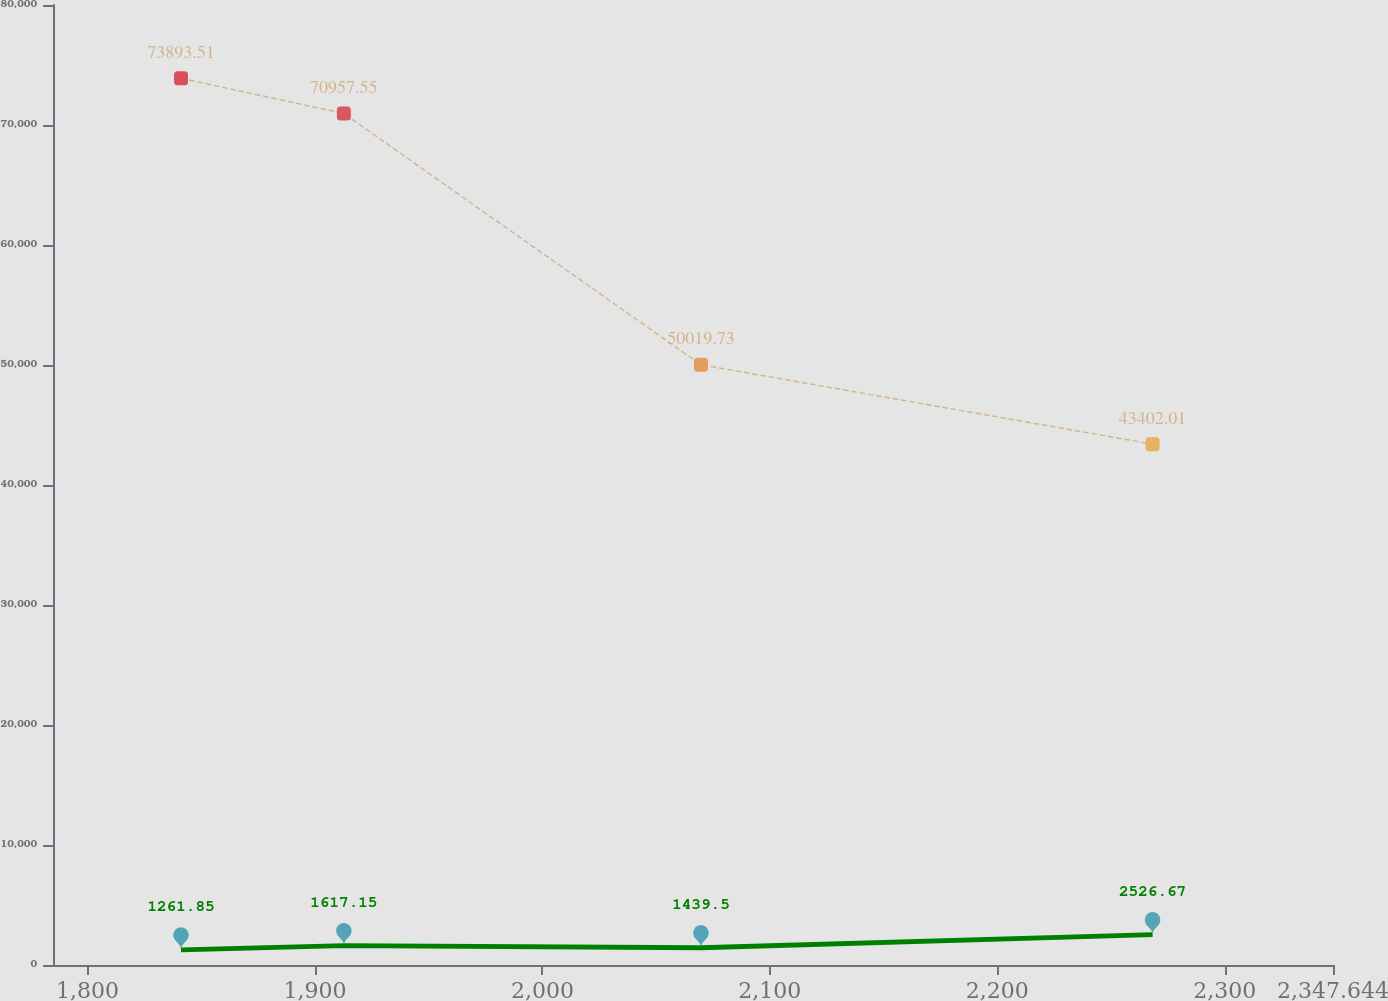Convert chart to OTSL. <chart><loc_0><loc_0><loc_500><loc_500><line_chart><ecel><fcel>Operating leases<fcel>Capital leases<nl><fcel>1841.07<fcel>73893.5<fcel>1261.85<nl><fcel>1912.69<fcel>70957.6<fcel>1617.15<nl><fcel>2069.71<fcel>50019.7<fcel>1439.5<nl><fcel>2268.31<fcel>43402<fcel>2526.67<nl><fcel>2403.93<fcel>47083.8<fcel>750.2<nl></chart> 